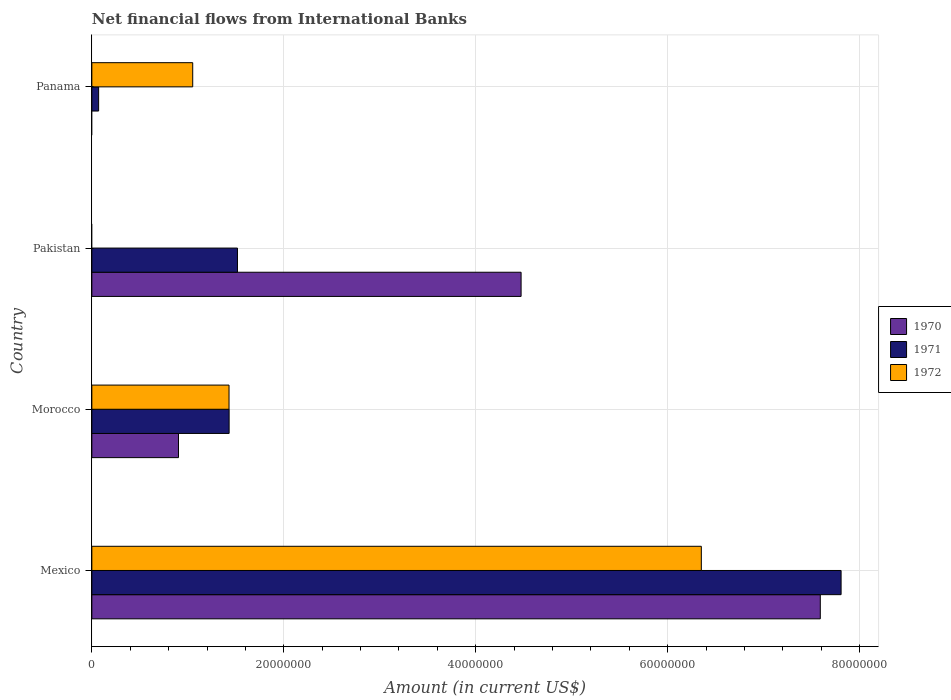How many different coloured bars are there?
Provide a short and direct response. 3. How many groups of bars are there?
Give a very brief answer. 4. Are the number of bars on each tick of the Y-axis equal?
Your response must be concise. No. How many bars are there on the 1st tick from the top?
Make the answer very short. 2. How many bars are there on the 2nd tick from the bottom?
Offer a terse response. 3. In how many cases, is the number of bars for a given country not equal to the number of legend labels?
Your answer should be compact. 2. What is the net financial aid flows in 1972 in Pakistan?
Make the answer very short. 0. Across all countries, what is the maximum net financial aid flows in 1972?
Your response must be concise. 6.35e+07. Across all countries, what is the minimum net financial aid flows in 1971?
Provide a short and direct response. 7.07e+05. What is the total net financial aid flows in 1971 in the graph?
Offer a terse response. 1.08e+08. What is the difference between the net financial aid flows in 1972 in Mexico and that in Panama?
Your answer should be compact. 5.30e+07. What is the difference between the net financial aid flows in 1970 in Pakistan and the net financial aid flows in 1971 in Mexico?
Provide a short and direct response. -3.33e+07. What is the average net financial aid flows in 1970 per country?
Offer a terse response. 3.24e+07. What is the difference between the net financial aid flows in 1971 and net financial aid flows in 1970 in Pakistan?
Make the answer very short. -2.96e+07. What is the ratio of the net financial aid flows in 1970 in Mexico to that in Morocco?
Provide a short and direct response. 8.41. Is the net financial aid flows in 1972 in Mexico less than that in Panama?
Offer a very short reply. No. What is the difference between the highest and the second highest net financial aid flows in 1970?
Your response must be concise. 3.12e+07. What is the difference between the highest and the lowest net financial aid flows in 1971?
Offer a terse response. 7.74e+07. In how many countries, is the net financial aid flows in 1971 greater than the average net financial aid flows in 1971 taken over all countries?
Provide a succinct answer. 1. Is the sum of the net financial aid flows in 1971 in Mexico and Pakistan greater than the maximum net financial aid flows in 1970 across all countries?
Make the answer very short. Yes. Is it the case that in every country, the sum of the net financial aid flows in 1972 and net financial aid flows in 1971 is greater than the net financial aid flows in 1970?
Keep it short and to the point. No. Are the values on the major ticks of X-axis written in scientific E-notation?
Keep it short and to the point. No. Where does the legend appear in the graph?
Offer a very short reply. Center right. How are the legend labels stacked?
Keep it short and to the point. Vertical. What is the title of the graph?
Your response must be concise. Net financial flows from International Banks. What is the label or title of the X-axis?
Give a very brief answer. Amount (in current US$). What is the label or title of the Y-axis?
Give a very brief answer. Country. What is the Amount (in current US$) of 1970 in Mexico?
Keep it short and to the point. 7.59e+07. What is the Amount (in current US$) in 1971 in Mexico?
Keep it short and to the point. 7.81e+07. What is the Amount (in current US$) in 1972 in Mexico?
Provide a short and direct response. 6.35e+07. What is the Amount (in current US$) in 1970 in Morocco?
Keep it short and to the point. 9.03e+06. What is the Amount (in current US$) in 1971 in Morocco?
Your response must be concise. 1.43e+07. What is the Amount (in current US$) in 1972 in Morocco?
Offer a terse response. 1.43e+07. What is the Amount (in current US$) in 1970 in Pakistan?
Offer a terse response. 4.47e+07. What is the Amount (in current US$) of 1971 in Pakistan?
Your answer should be very brief. 1.52e+07. What is the Amount (in current US$) of 1972 in Pakistan?
Provide a short and direct response. 0. What is the Amount (in current US$) in 1970 in Panama?
Make the answer very short. 0. What is the Amount (in current US$) of 1971 in Panama?
Your response must be concise. 7.07e+05. What is the Amount (in current US$) in 1972 in Panama?
Keep it short and to the point. 1.05e+07. Across all countries, what is the maximum Amount (in current US$) in 1970?
Offer a very short reply. 7.59e+07. Across all countries, what is the maximum Amount (in current US$) in 1971?
Your answer should be very brief. 7.81e+07. Across all countries, what is the maximum Amount (in current US$) of 1972?
Your answer should be very brief. 6.35e+07. Across all countries, what is the minimum Amount (in current US$) in 1971?
Provide a short and direct response. 7.07e+05. What is the total Amount (in current US$) in 1970 in the graph?
Keep it short and to the point. 1.30e+08. What is the total Amount (in current US$) in 1971 in the graph?
Offer a terse response. 1.08e+08. What is the total Amount (in current US$) in 1972 in the graph?
Ensure brevity in your answer.  8.83e+07. What is the difference between the Amount (in current US$) in 1970 in Mexico and that in Morocco?
Keep it short and to the point. 6.69e+07. What is the difference between the Amount (in current US$) in 1971 in Mexico and that in Morocco?
Give a very brief answer. 6.38e+07. What is the difference between the Amount (in current US$) of 1972 in Mexico and that in Morocco?
Your answer should be very brief. 4.92e+07. What is the difference between the Amount (in current US$) of 1970 in Mexico and that in Pakistan?
Keep it short and to the point. 3.12e+07. What is the difference between the Amount (in current US$) in 1971 in Mexico and that in Pakistan?
Keep it short and to the point. 6.29e+07. What is the difference between the Amount (in current US$) in 1971 in Mexico and that in Panama?
Ensure brevity in your answer.  7.74e+07. What is the difference between the Amount (in current US$) of 1972 in Mexico and that in Panama?
Your answer should be very brief. 5.30e+07. What is the difference between the Amount (in current US$) in 1970 in Morocco and that in Pakistan?
Ensure brevity in your answer.  -3.57e+07. What is the difference between the Amount (in current US$) of 1971 in Morocco and that in Pakistan?
Give a very brief answer. -8.69e+05. What is the difference between the Amount (in current US$) of 1971 in Morocco and that in Panama?
Your response must be concise. 1.36e+07. What is the difference between the Amount (in current US$) of 1972 in Morocco and that in Panama?
Provide a short and direct response. 3.78e+06. What is the difference between the Amount (in current US$) of 1971 in Pakistan and that in Panama?
Provide a succinct answer. 1.45e+07. What is the difference between the Amount (in current US$) of 1970 in Mexico and the Amount (in current US$) of 1971 in Morocco?
Give a very brief answer. 6.16e+07. What is the difference between the Amount (in current US$) in 1970 in Mexico and the Amount (in current US$) in 1972 in Morocco?
Ensure brevity in your answer.  6.16e+07. What is the difference between the Amount (in current US$) of 1971 in Mexico and the Amount (in current US$) of 1972 in Morocco?
Your answer should be very brief. 6.38e+07. What is the difference between the Amount (in current US$) in 1970 in Mexico and the Amount (in current US$) in 1971 in Pakistan?
Your response must be concise. 6.07e+07. What is the difference between the Amount (in current US$) in 1970 in Mexico and the Amount (in current US$) in 1971 in Panama?
Make the answer very short. 7.52e+07. What is the difference between the Amount (in current US$) of 1970 in Mexico and the Amount (in current US$) of 1972 in Panama?
Ensure brevity in your answer.  6.54e+07. What is the difference between the Amount (in current US$) in 1971 in Mexico and the Amount (in current US$) in 1972 in Panama?
Offer a terse response. 6.76e+07. What is the difference between the Amount (in current US$) in 1970 in Morocco and the Amount (in current US$) in 1971 in Pakistan?
Make the answer very short. -6.14e+06. What is the difference between the Amount (in current US$) of 1970 in Morocco and the Amount (in current US$) of 1971 in Panama?
Your answer should be very brief. 8.32e+06. What is the difference between the Amount (in current US$) of 1970 in Morocco and the Amount (in current US$) of 1972 in Panama?
Provide a succinct answer. -1.48e+06. What is the difference between the Amount (in current US$) of 1971 in Morocco and the Amount (in current US$) of 1972 in Panama?
Give a very brief answer. 3.79e+06. What is the difference between the Amount (in current US$) of 1970 in Pakistan and the Amount (in current US$) of 1971 in Panama?
Your answer should be compact. 4.40e+07. What is the difference between the Amount (in current US$) in 1970 in Pakistan and the Amount (in current US$) in 1972 in Panama?
Your answer should be very brief. 3.42e+07. What is the difference between the Amount (in current US$) in 1971 in Pakistan and the Amount (in current US$) in 1972 in Panama?
Provide a short and direct response. 4.66e+06. What is the average Amount (in current US$) of 1970 per country?
Ensure brevity in your answer.  3.24e+07. What is the average Amount (in current US$) of 1971 per country?
Offer a very short reply. 2.71e+07. What is the average Amount (in current US$) in 1972 per country?
Your answer should be very brief. 2.21e+07. What is the difference between the Amount (in current US$) of 1970 and Amount (in current US$) of 1971 in Mexico?
Provide a succinct answer. -2.17e+06. What is the difference between the Amount (in current US$) of 1970 and Amount (in current US$) of 1972 in Mexico?
Ensure brevity in your answer.  1.24e+07. What is the difference between the Amount (in current US$) of 1971 and Amount (in current US$) of 1972 in Mexico?
Make the answer very short. 1.46e+07. What is the difference between the Amount (in current US$) of 1970 and Amount (in current US$) of 1971 in Morocco?
Make the answer very short. -5.28e+06. What is the difference between the Amount (in current US$) in 1970 and Amount (in current US$) in 1972 in Morocco?
Keep it short and to the point. -5.27e+06. What is the difference between the Amount (in current US$) of 1970 and Amount (in current US$) of 1971 in Pakistan?
Offer a very short reply. 2.96e+07. What is the difference between the Amount (in current US$) in 1971 and Amount (in current US$) in 1972 in Panama?
Keep it short and to the point. -9.80e+06. What is the ratio of the Amount (in current US$) in 1970 in Mexico to that in Morocco?
Your answer should be compact. 8.41. What is the ratio of the Amount (in current US$) of 1971 in Mexico to that in Morocco?
Your answer should be compact. 5.46. What is the ratio of the Amount (in current US$) in 1972 in Mexico to that in Morocco?
Your response must be concise. 4.44. What is the ratio of the Amount (in current US$) of 1970 in Mexico to that in Pakistan?
Keep it short and to the point. 1.7. What is the ratio of the Amount (in current US$) of 1971 in Mexico to that in Pakistan?
Make the answer very short. 5.15. What is the ratio of the Amount (in current US$) in 1971 in Mexico to that in Panama?
Provide a succinct answer. 110.43. What is the ratio of the Amount (in current US$) of 1972 in Mexico to that in Panama?
Your response must be concise. 6.04. What is the ratio of the Amount (in current US$) of 1970 in Morocco to that in Pakistan?
Offer a very short reply. 0.2. What is the ratio of the Amount (in current US$) of 1971 in Morocco to that in Pakistan?
Make the answer very short. 0.94. What is the ratio of the Amount (in current US$) in 1971 in Morocco to that in Panama?
Your answer should be compact. 20.23. What is the ratio of the Amount (in current US$) in 1972 in Morocco to that in Panama?
Provide a short and direct response. 1.36. What is the ratio of the Amount (in current US$) in 1971 in Pakistan to that in Panama?
Your response must be concise. 21.46. What is the difference between the highest and the second highest Amount (in current US$) in 1970?
Offer a terse response. 3.12e+07. What is the difference between the highest and the second highest Amount (in current US$) in 1971?
Provide a succinct answer. 6.29e+07. What is the difference between the highest and the second highest Amount (in current US$) of 1972?
Ensure brevity in your answer.  4.92e+07. What is the difference between the highest and the lowest Amount (in current US$) of 1970?
Give a very brief answer. 7.59e+07. What is the difference between the highest and the lowest Amount (in current US$) of 1971?
Your response must be concise. 7.74e+07. What is the difference between the highest and the lowest Amount (in current US$) in 1972?
Provide a succinct answer. 6.35e+07. 